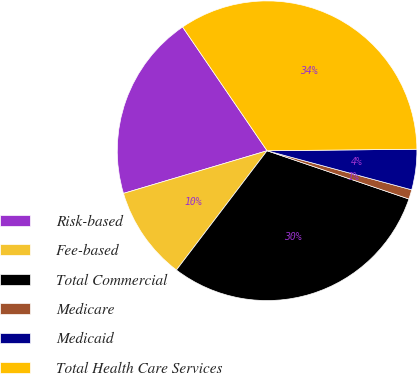Convert chart to OTSL. <chart><loc_0><loc_0><loc_500><loc_500><pie_chart><fcel>Risk-based<fcel>Fee-based<fcel>Total Commercial<fcel>Medicare<fcel>Medicaid<fcel>Total Health Care Services<nl><fcel>20.06%<fcel>10.06%<fcel>30.12%<fcel>1.02%<fcel>4.36%<fcel>34.37%<nl></chart> 